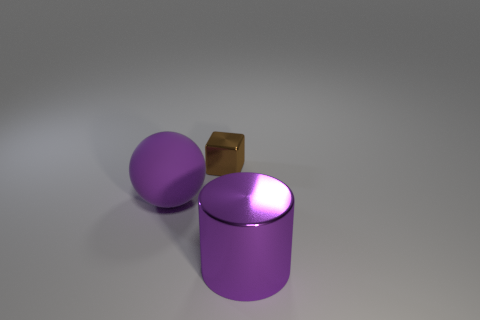Subtract all small metal objects. Subtract all tiny yellow metal spheres. How many objects are left? 2 Add 2 large purple matte balls. How many large purple matte balls are left? 3 Add 3 metal objects. How many metal objects exist? 5 Add 2 brown rubber objects. How many objects exist? 5 Subtract 0 green spheres. How many objects are left? 3 Subtract all balls. How many objects are left? 2 Subtract 1 spheres. How many spheres are left? 0 Subtract all cyan blocks. Subtract all gray cylinders. How many blocks are left? 1 